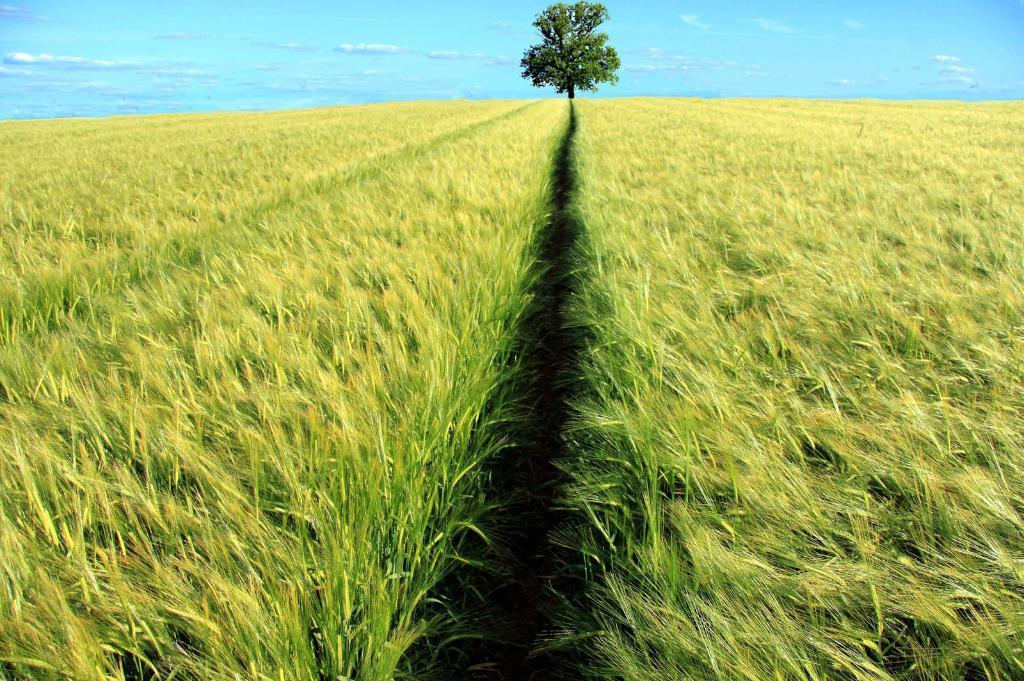Please provide a concise description of this image. In this image there are fields and in the background there is a tree. 